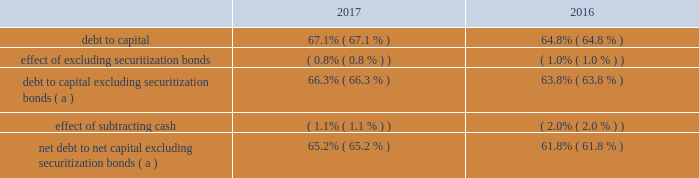Operations may be extended up to four additional years for each unit by mutual agreement of entergy and new york state based on an exigent reliability need for indian point generation .
In accordance with the ferc-approved tariff of the new york independent system operator ( nyiso ) , entergy submitted to the nyiso a notice of generator deactivation based on the dates in the settlement ( no later than april 30 , 2020 for indian point unit 2 and april 30 , 2021 for indian point unit 3 ) .
In december 2017 , nyiso issued a report stating there will not be a system reliability need following the deactivation of indian point .
The nyiso also has advised that it will perform an analysis of the potential competitive impacts of the proposed retirement under provisions of its tariff .
The deadline for the nyiso to make a withholding determination is in dispute and is pending before the ferc .
In addition to contractually agreeing to cease commercial operations early , in february 2017 entergy filed with the nrc an amendment to its license renewal application changing the term of the requested licenses to coincide with the latest possible extension by mutual agreement based on exigent reliability needs : april 30 , 2024 for indian point 2 and april 30 , 2025 for indian point 3 .
If entergy reasonably determines that the nrc will treat the amendment other than as a routine amendment , entergy may withdraw the amendment .
Other provisions of the settlement include termination of all then-existing investigations of indian point by the agencies signing the agreement , which include the new york state department of environmental conservation , the new york state department of state , the new york state department of public service , the new york state department of health , and the new york state attorney general .
The settlement recognizes the right of new york state agencies to pursue new investigations and enforcement actions with respect to new circumstances or existing conditions that become materially exacerbated .
Another provision of the settlement obligates entergy to establish a $ 15 million fund for environmental projects and community support .
Apportionment and allocation of funds to beneficiaries are to be determined by mutual agreement of new york state and entergy .
The settlement recognizes new york state 2019s right to perform an annual inspection of indian point , with scope and timing to be determined by mutual agreement .
In may 2017 a plaintiff filed two parallel state court appeals challenging new york state 2019s actions in signing and implementing the indian point settlement with entergy on the basis that the state failed to perform sufficient environmental analysis of its actions .
All signatories to the settlement agreement , including the entergy affiliates that hold nrc licenses for indian point , were named .
The appeals were voluntarily dismissed in november 2017 .
Entergy corporation and subsidiaries management 2019s financial discussion and analysis liquidity and capital resources this section discusses entergy 2019s capital structure , capital spending plans and other uses of capital , sources of capital , and the cash flow activity presented in the cash flow statement .
Capital structure entergy 2019s capitalization is balanced between equity and debt , as shown in the table .
The increase in the debt to capital ratio for entergy as of december 31 , 2017 is primarily due to an increase in commercial paper outstanding in 2017 as compared to 2016. .
( a ) calculation excludes the arkansas , louisiana , new orleans , and texas securitization bonds , which are non- recourse to entergy arkansas , entergy louisiana , entergy new orleans , and entergy texas , respectively. .
What is the percentage change in the debt-to-capital ratio from 2016 to 2017? 
Computations: ((67.1 - 64.8) / 64.8)
Answer: 0.03549. 